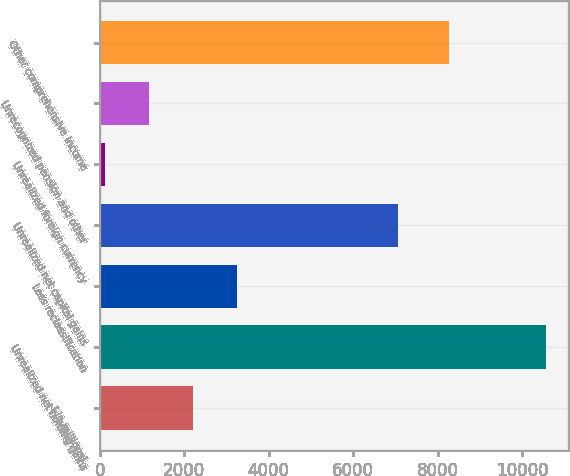Convert chart to OTSL. <chart><loc_0><loc_0><loc_500><loc_500><bar_chart><fcel>( in millions)<fcel>Unrealized net holding gains<fcel>Less reclassification<fcel>Unrealized net capital gains<fcel>Unrealized foreign currency<fcel>Unrecognized pension and other<fcel>Other comprehensive income<nl><fcel>2204.6<fcel>10567<fcel>3249.9<fcel>7058<fcel>114<fcel>1159.3<fcel>8275<nl></chart> 